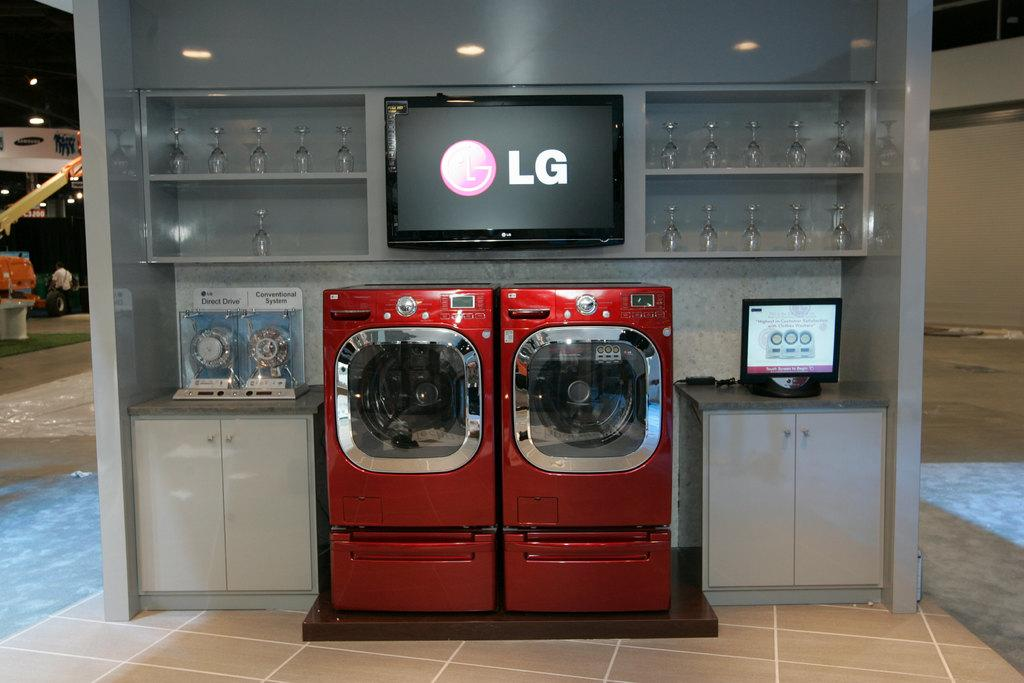<image>
Offer a succinct explanation of the picture presented. red lg washer and dryer with white cabionets on the bottom 